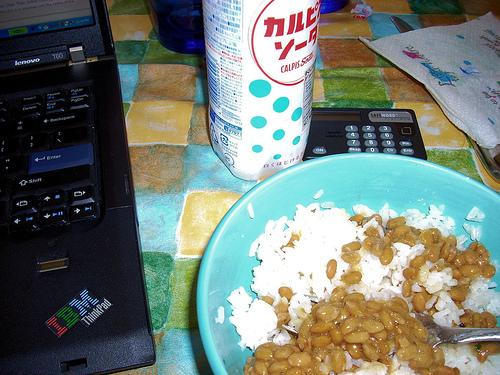Where is the calculator?
Be succinct. On table. What brand is the computer?
Give a very brief answer. Ibm. What language is on the can?
Give a very brief answer. Chinese. 